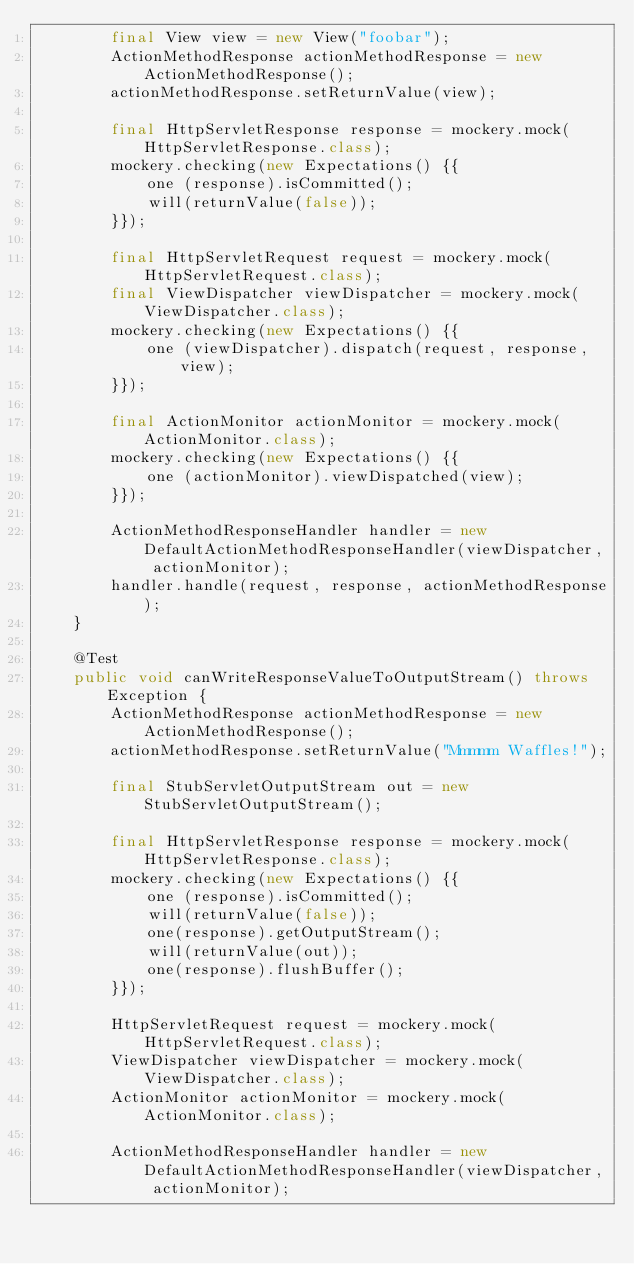Convert code to text. <code><loc_0><loc_0><loc_500><loc_500><_Java_>        final View view = new View("foobar");
        ActionMethodResponse actionMethodResponse = new ActionMethodResponse();
        actionMethodResponse.setReturnValue(view);

        final HttpServletResponse response = mockery.mock(HttpServletResponse.class);
        mockery.checking(new Expectations() {{
            one (response).isCommitted();
            will(returnValue(false));
        }});

        final HttpServletRequest request = mockery.mock(HttpServletRequest.class);
        final ViewDispatcher viewDispatcher = mockery.mock(ViewDispatcher.class);
        mockery.checking(new Expectations() {{
            one (viewDispatcher).dispatch(request, response, view);
        }});
        
        final ActionMonitor actionMonitor = mockery.mock(ActionMonitor.class);
        mockery.checking(new Expectations() {{
            one (actionMonitor).viewDispatched(view);
        }});

        ActionMethodResponseHandler handler = new DefaultActionMethodResponseHandler(viewDispatcher, actionMonitor);
        handler.handle(request, response, actionMethodResponse);
    }

    @Test
    public void canWriteResponseValueToOutputStream() throws Exception {
        ActionMethodResponse actionMethodResponse = new ActionMethodResponse();
        actionMethodResponse.setReturnValue("Mmmmm Waffles!");

        final StubServletOutputStream out = new StubServletOutputStream();

        final HttpServletResponse response = mockery.mock(HttpServletResponse.class);
        mockery.checking(new Expectations() {{
            one (response).isCommitted();
            will(returnValue(false));
            one(response).getOutputStream();
            will(returnValue(out));
            one(response).flushBuffer();
        }});

        HttpServletRequest request = mockery.mock(HttpServletRequest.class);
        ViewDispatcher viewDispatcher = mockery.mock(ViewDispatcher.class);
        ActionMonitor actionMonitor = mockery.mock(ActionMonitor.class);

        ActionMethodResponseHandler handler = new DefaultActionMethodResponseHandler(viewDispatcher, actionMonitor);</code> 